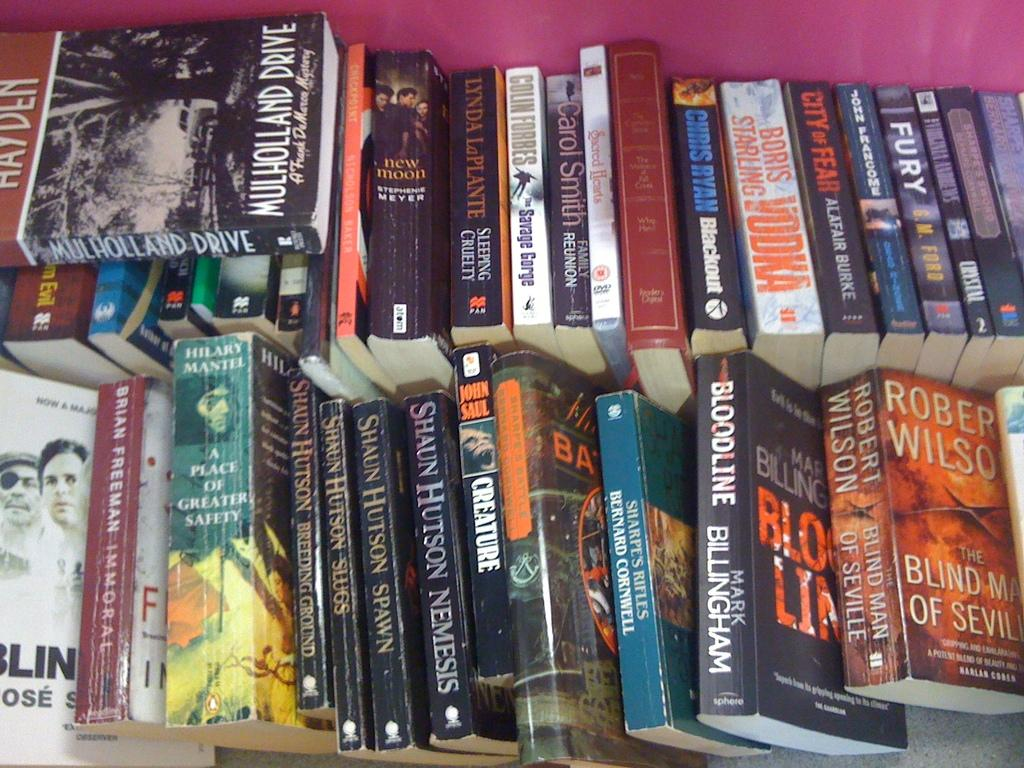<image>
Give a short and clear explanation of the subsequent image. Two rows of sevral books stacked side to side with mullholland drive on the top stack. 